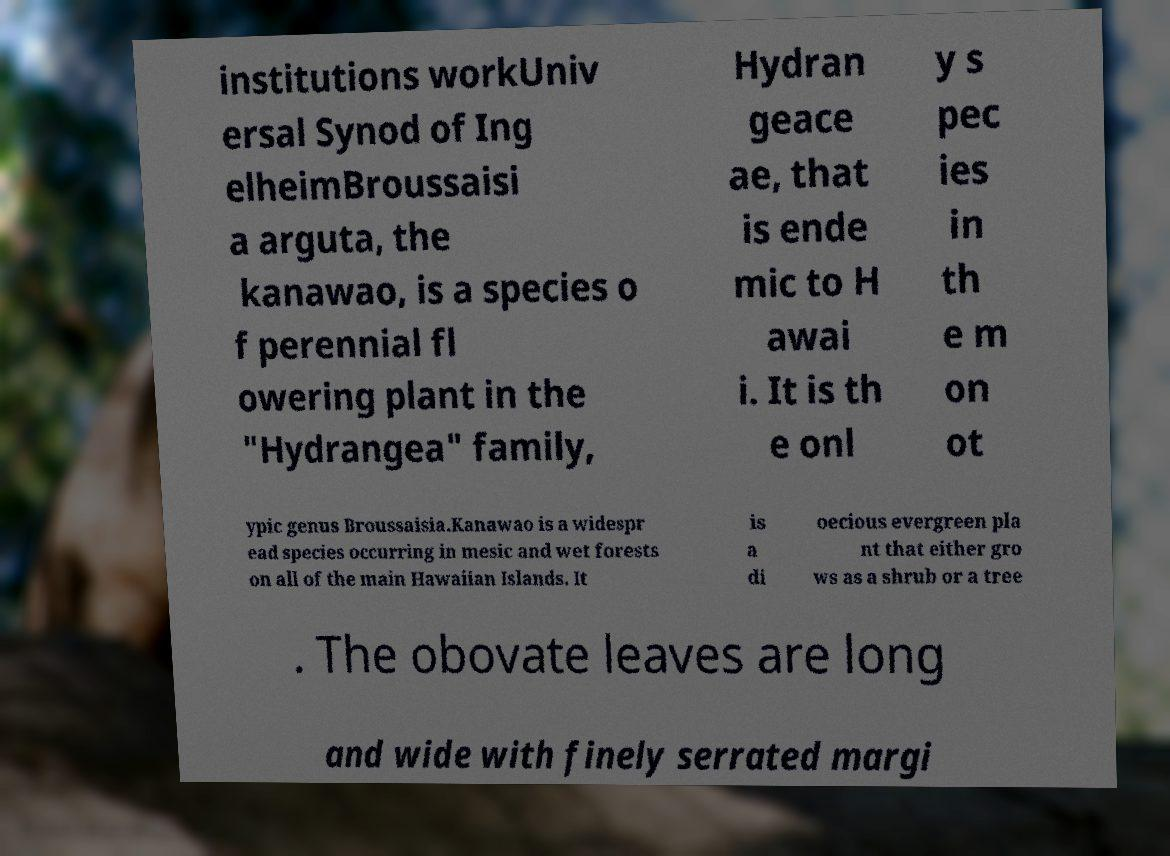Could you extract and type out the text from this image? institutions workUniv ersal Synod of Ing elheimBroussaisi a arguta, the kanawao, is a species o f perennial fl owering plant in the "Hydrangea" family, Hydran geace ae, that is ende mic to H awai i. It is th e onl y s pec ies in th e m on ot ypic genus Broussaisia.Kanawao is a widespr ead species occurring in mesic and wet forests on all of the main Hawaiian Islands. It is a di oecious evergreen pla nt that either gro ws as a shrub or a tree . The obovate leaves are long and wide with finely serrated margi 